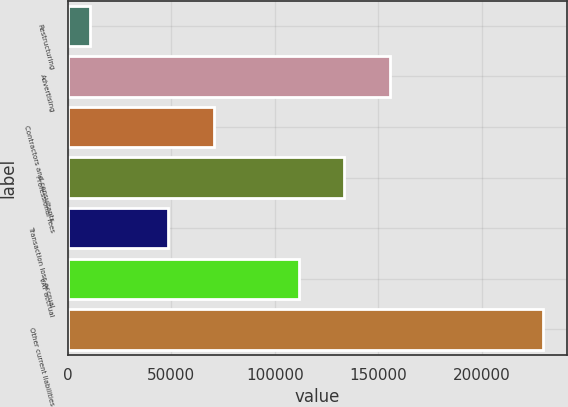<chart> <loc_0><loc_0><loc_500><loc_500><bar_chart><fcel>Restructuring<fcel>Advertising<fcel>Contractors and consultants<fcel>Professional fees<fcel>Transaction loss accrual<fcel>VAT accrual<fcel>Other current liabilities<nl><fcel>10909<fcel>155501<fcel>70443.2<fcel>133633<fcel>48575<fcel>111765<fcel>229591<nl></chart> 